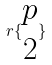<formula> <loc_0><loc_0><loc_500><loc_500>r \{ \begin{matrix} p \\ 2 \end{matrix} \}</formula> 